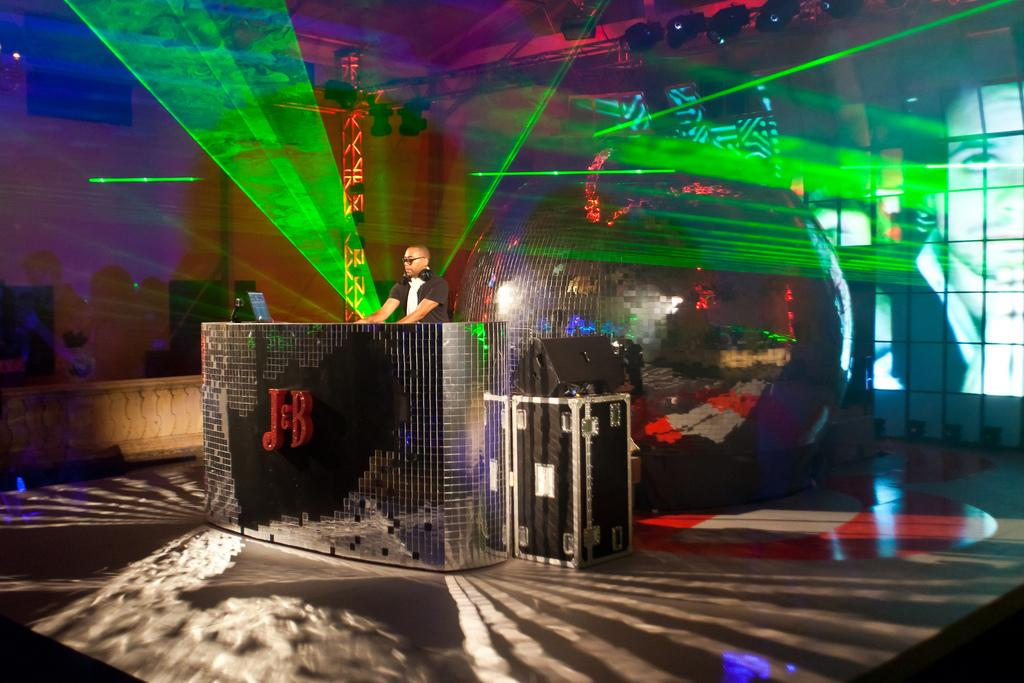What piece of furniture is in the image? There is a table in the image. What object is placed on the table? A laptop is present on the table. What is the person in the image doing? The person is standing in the image. What can be seen on the person's head? The person is wearing headphones. What can be seen in the background of the image? There are light focuses visible in the background. What type of berry is being combed in the image? There is no berry or comb present in the image. How many light sources are visible in the image? The question cannot be answered definitively as the number of light focuses is not specified in the facts. 